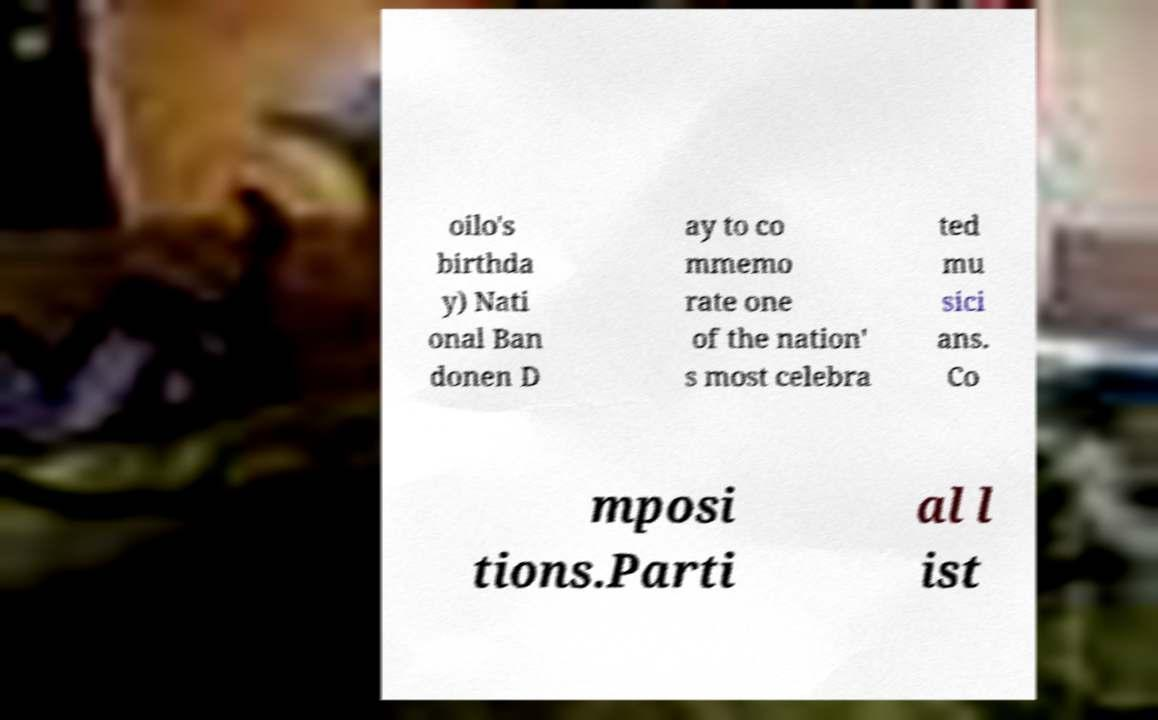Please read and relay the text visible in this image. What does it say? oilo's birthda y) Nati onal Ban donen D ay to co mmemo rate one of the nation' s most celebra ted mu sici ans. Co mposi tions.Parti al l ist 